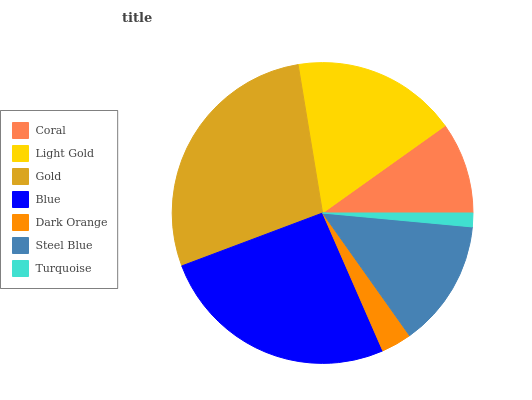Is Turquoise the minimum?
Answer yes or no. Yes. Is Gold the maximum?
Answer yes or no. Yes. Is Light Gold the minimum?
Answer yes or no. No. Is Light Gold the maximum?
Answer yes or no. No. Is Light Gold greater than Coral?
Answer yes or no. Yes. Is Coral less than Light Gold?
Answer yes or no. Yes. Is Coral greater than Light Gold?
Answer yes or no. No. Is Light Gold less than Coral?
Answer yes or no. No. Is Steel Blue the high median?
Answer yes or no. Yes. Is Steel Blue the low median?
Answer yes or no. Yes. Is Dark Orange the high median?
Answer yes or no. No. Is Gold the low median?
Answer yes or no. No. 